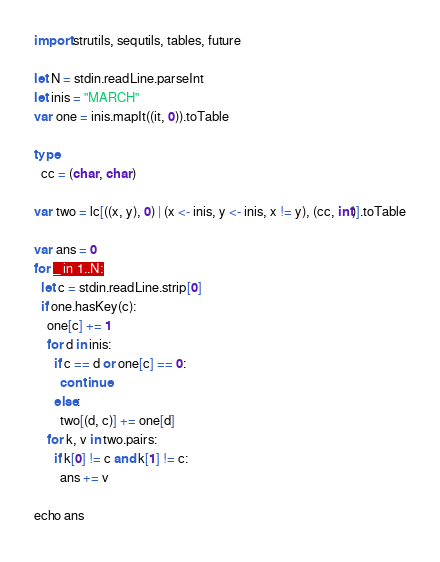<code> <loc_0><loc_0><loc_500><loc_500><_Nim_>import strutils, sequtils, tables, future

let N = stdin.readLine.parseInt
let inis = "MARCH"
var one = inis.mapIt((it, 0)).toTable

type
  cc = (char, char)

var two = lc[((x, y), 0) | (x <- inis, y <- inis, x != y), (cc, int)].toTable

var ans = 0
for _ in 1..N:
  let c = stdin.readLine.strip[0]
  if one.hasKey(c):
    one[c] += 1
    for d in inis:
      if c == d or one[c] == 0:
        continue
      else:
        two[(d, c)] += one[d]
    for k, v in two.pairs:
      if k[0] != c and k[1] != c:
        ans += v

echo ans</code> 